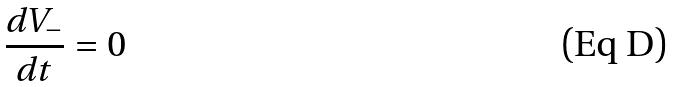<formula> <loc_0><loc_0><loc_500><loc_500>\frac { d V _ { - } } { d t } = 0</formula> 